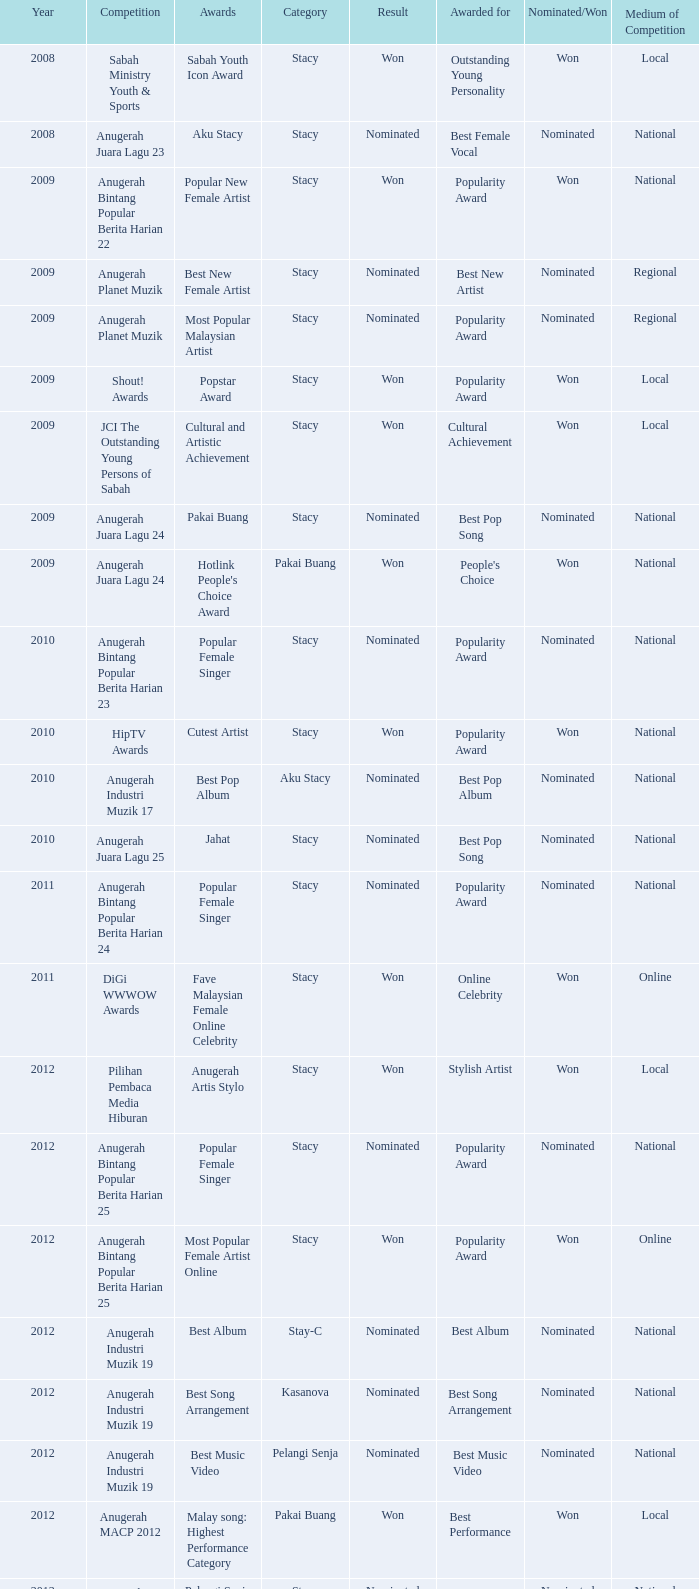What was the result in the year greaters than 2008 with an award of Jahat and had a category of Stacy? Nominated. 